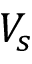Convert formula to latex. <formula><loc_0><loc_0><loc_500><loc_500>V _ { s }</formula> 